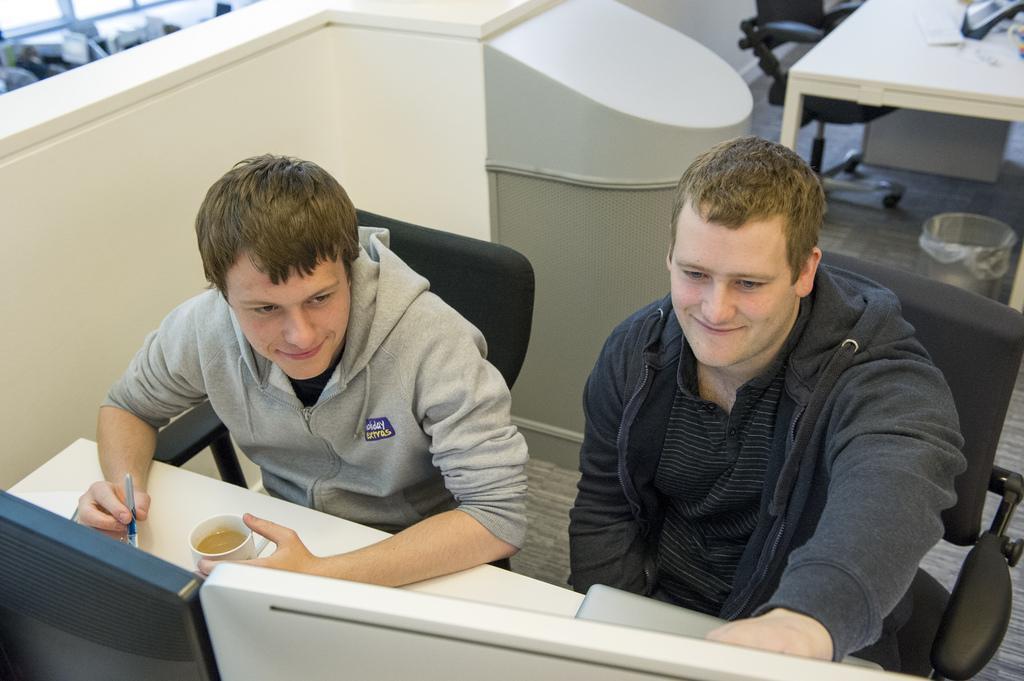How would you summarize this image in a sentence or two? I think this picture is taken in an office. There are two men sitting on chairs and leaning on a table. A person to the left, he is wearing a grey sweater and holding a cup and a pen in his hands. A person to the right he is wearing a black sweater and black T shirt. There are two monitors before them. In the background there is a chair, table, a dustbin and a cubicle board. 